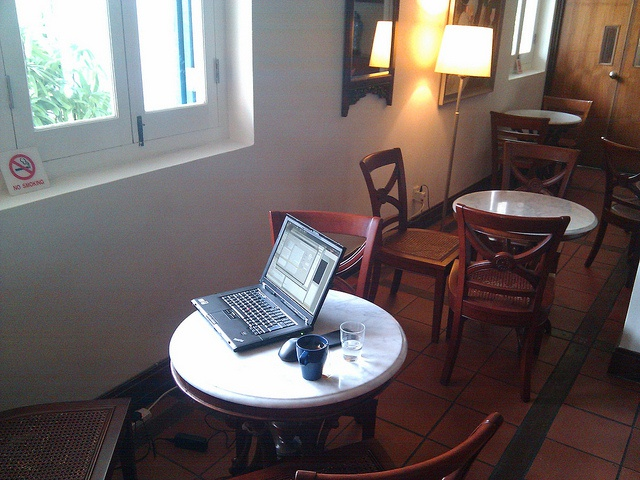Describe the objects in this image and their specific colors. I can see dining table in darkgray, white, gray, and lavender tones, chair in darkgray, black, maroon, and gray tones, chair in darkgray, black, and gray tones, laptop in darkgray, lightgray, and gray tones, and chair in darkgray, black, maroon, and gray tones in this image. 